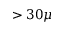<formula> <loc_0><loc_0><loc_500><loc_500>> 3 0 \mu</formula> 